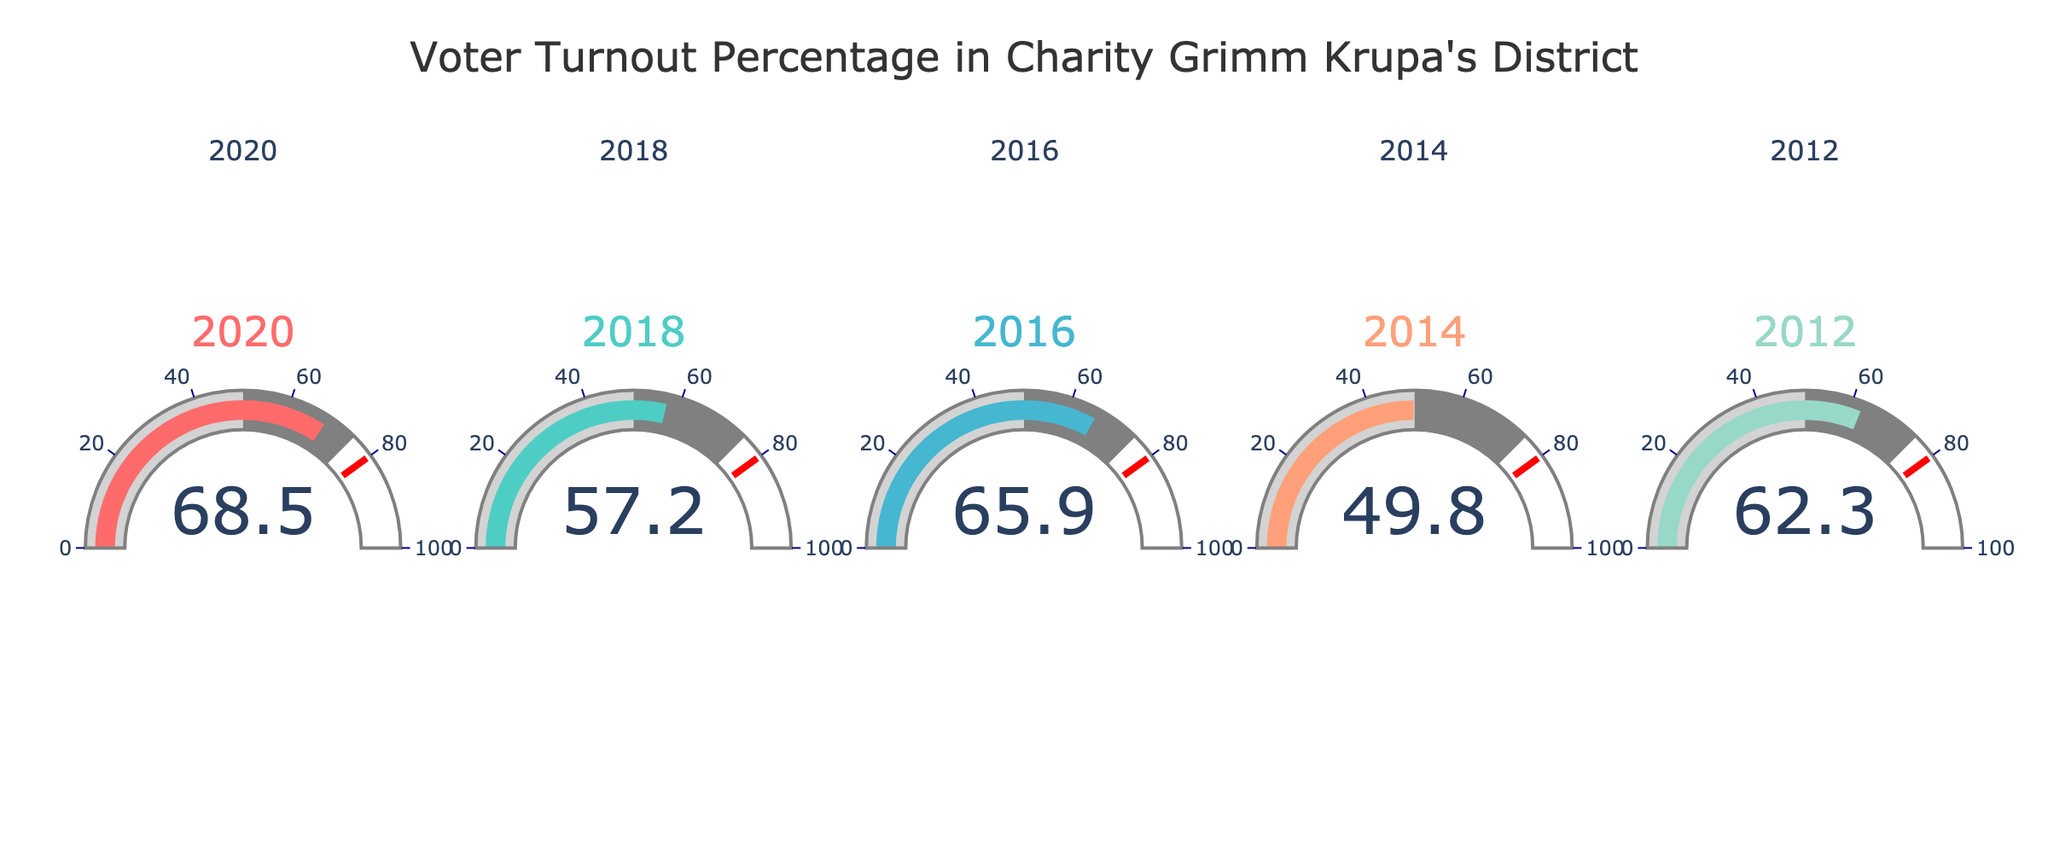What's the voter turnout percentage in 2020? The voter turnout percentage in 2020 can be directly read off the gauge corresponding to the year 2020.
Answer: 68.5% What's the range of years displayed in the figure? The figure shows gauges for five different years. The oldest displayed year is 2012, and the most recent one is 2020.
Answer: 2012 to 2020 Which year had the lowest voter turnout percentage? The gauge with the lowest value represents the year with the lowest voter turnout percentage. From the figure, the lowest percentage is around 49.8%, which corresponds to the year 2014.
Answer: 2014 What's the total voter turnout percentage across all shown years? Add the voter turnout percentages for all the displayed years: 68.5 + 57.2 + 65.9 + 49.8 + 62.3 = 303.7
Answer: 303.7 How does the voter turnout in 2018 compare to that in 2012? Compare the values on the gauges for the years 2018 and 2012. 2018 has 57.2%, and 2012 has 62.3%, so 2018's turnout is slightly lower.
Answer: 57.2% < 62.3% What's the average voter turnout percentage over the years shown? Calculate the average by adding the percentages and dividing by the number of years: (68.5 + 57.2 + 65.9 + 49.8 + 62.3) / 5 = 60.74.
Answer: 60.74% How does the voter turnout threshold of 80% compare to the displayed voter turnout percentages? On each gauge, an indicator line at 80% can be seen. All voter turnout percentages in this figure are below this threshold, as none of the values reach 80% or higher.
Answer: All values are below 80% Did voter turnout increase or decrease from 2014 to 2016? Compare the voter turnout percentages for 2014 and 2016. The turnout increased from 49.8% to 65.9%.
Answer: Increased 